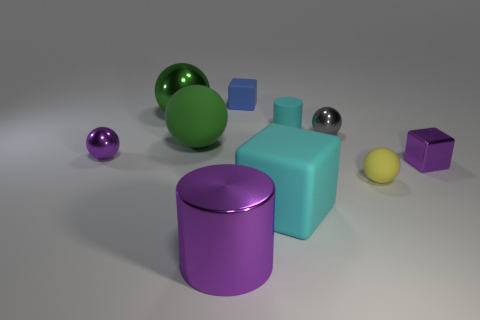Subtract all yellow cylinders. How many green balls are left? 2 Subtract all small gray spheres. How many spheres are left? 4 Subtract all purple balls. How many balls are left? 4 Subtract all brown spheres. Subtract all brown blocks. How many spheres are left? 5 Subtract all cubes. How many objects are left? 7 Subtract all spheres. Subtract all large green balls. How many objects are left? 3 Add 4 large cyan matte things. How many large cyan matte things are left? 5 Add 9 yellow spheres. How many yellow spheres exist? 10 Subtract 1 purple cylinders. How many objects are left? 9 